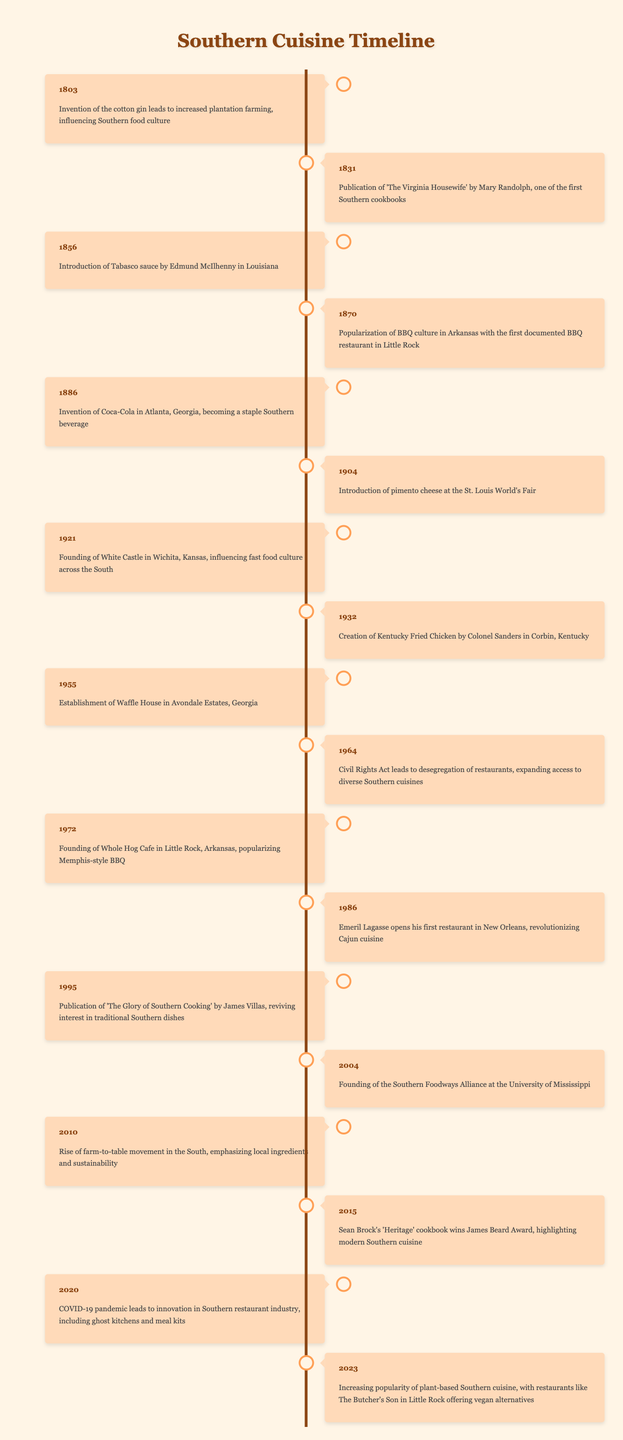What event occurred in 1831? The table shows that the publication of 'The Virginia Housewife' by Mary Randolph occurred in 1831, which is listed as one of the first Southern cookbooks.
Answer: Publication of 'The Virginia Housewife' What beverage was invented in 1886? According to the timeline, Coca-Cola was invented in Atlanta, Georgia in 1886, becoming a staple Southern beverage.
Answer: Coca-Cola Which two events are related to BBQ culture? From the table, the first event related to BBQ culture is the popularization of BBQ culture in Arkansas in 1870, and the founding of Whole Hog Cafe in Little Rock in 1972, which popularized Memphis-style BBQ.
Answer: 1870 and 1972 How many years are there between the invention of Coca-Cola and the establishment of Waffle House? The invention of Coca-Cola occurred in 1886 and the establishment of Waffle House occurred in 1955. The difference in years is 1955 - 1886 = 69 years.
Answer: 69 years Did the Civil Rights Act affect Southern cuisine? Yes, the table indicates that the Civil Rights Act in 1964 led to the desegregation of restaurants, which expanded access to diverse Southern cuisines.
Answer: Yes What is the significance of 2010 in the timeline? The year 2010 marks the rise of the farm-to-table movement in the South, which emphasizes local ingredients and sustainability. This reflects a shift in culinary practices towards more sustainable eating.
Answer: Rise of the farm-to-table movement When did the increasing popularity of plant-based Southern cuisine begin? The timeline indicates that the increasing popularity of plant-based Southern cuisine became notable in 2023, with examples like The Butcher's Son in Little Rock offering vegan alternatives.
Answer: 2023 Which event directly relates to Colonel Sanders? The creation of Kentucky Fried Chicken by Colonel Sanders took place in 1932 in Corbin, Kentucky, and is specifically mentioned in the timeline.
Answer: Creation of Kentucky Fried Chicken What trends have emerged in Southern cuisine due to COVID-19? In 2020, the timeline highlights that the COVID-19 pandemic led to innovation in the Southern restaurant industry, including the development of ghost kitchens and meal kits.
Answer: Innovation in restaurant industry 